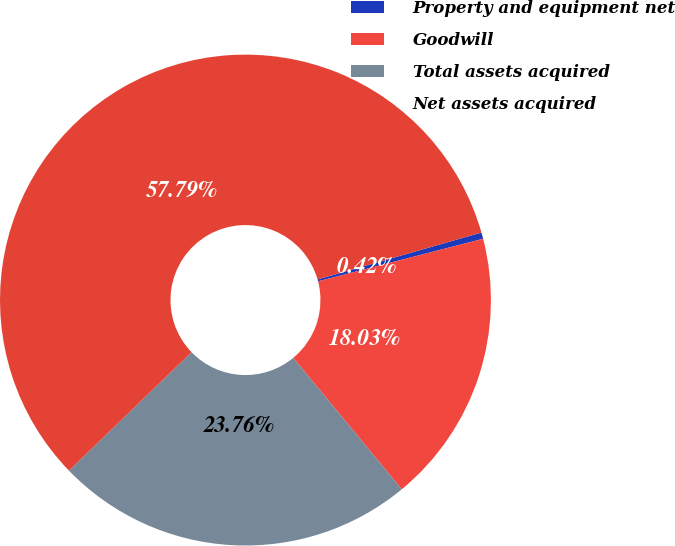Convert chart. <chart><loc_0><loc_0><loc_500><loc_500><pie_chart><fcel>Property and equipment net<fcel>Goodwill<fcel>Total assets acquired<fcel>Net assets acquired<nl><fcel>0.42%<fcel>18.03%<fcel>23.76%<fcel>57.79%<nl></chart> 